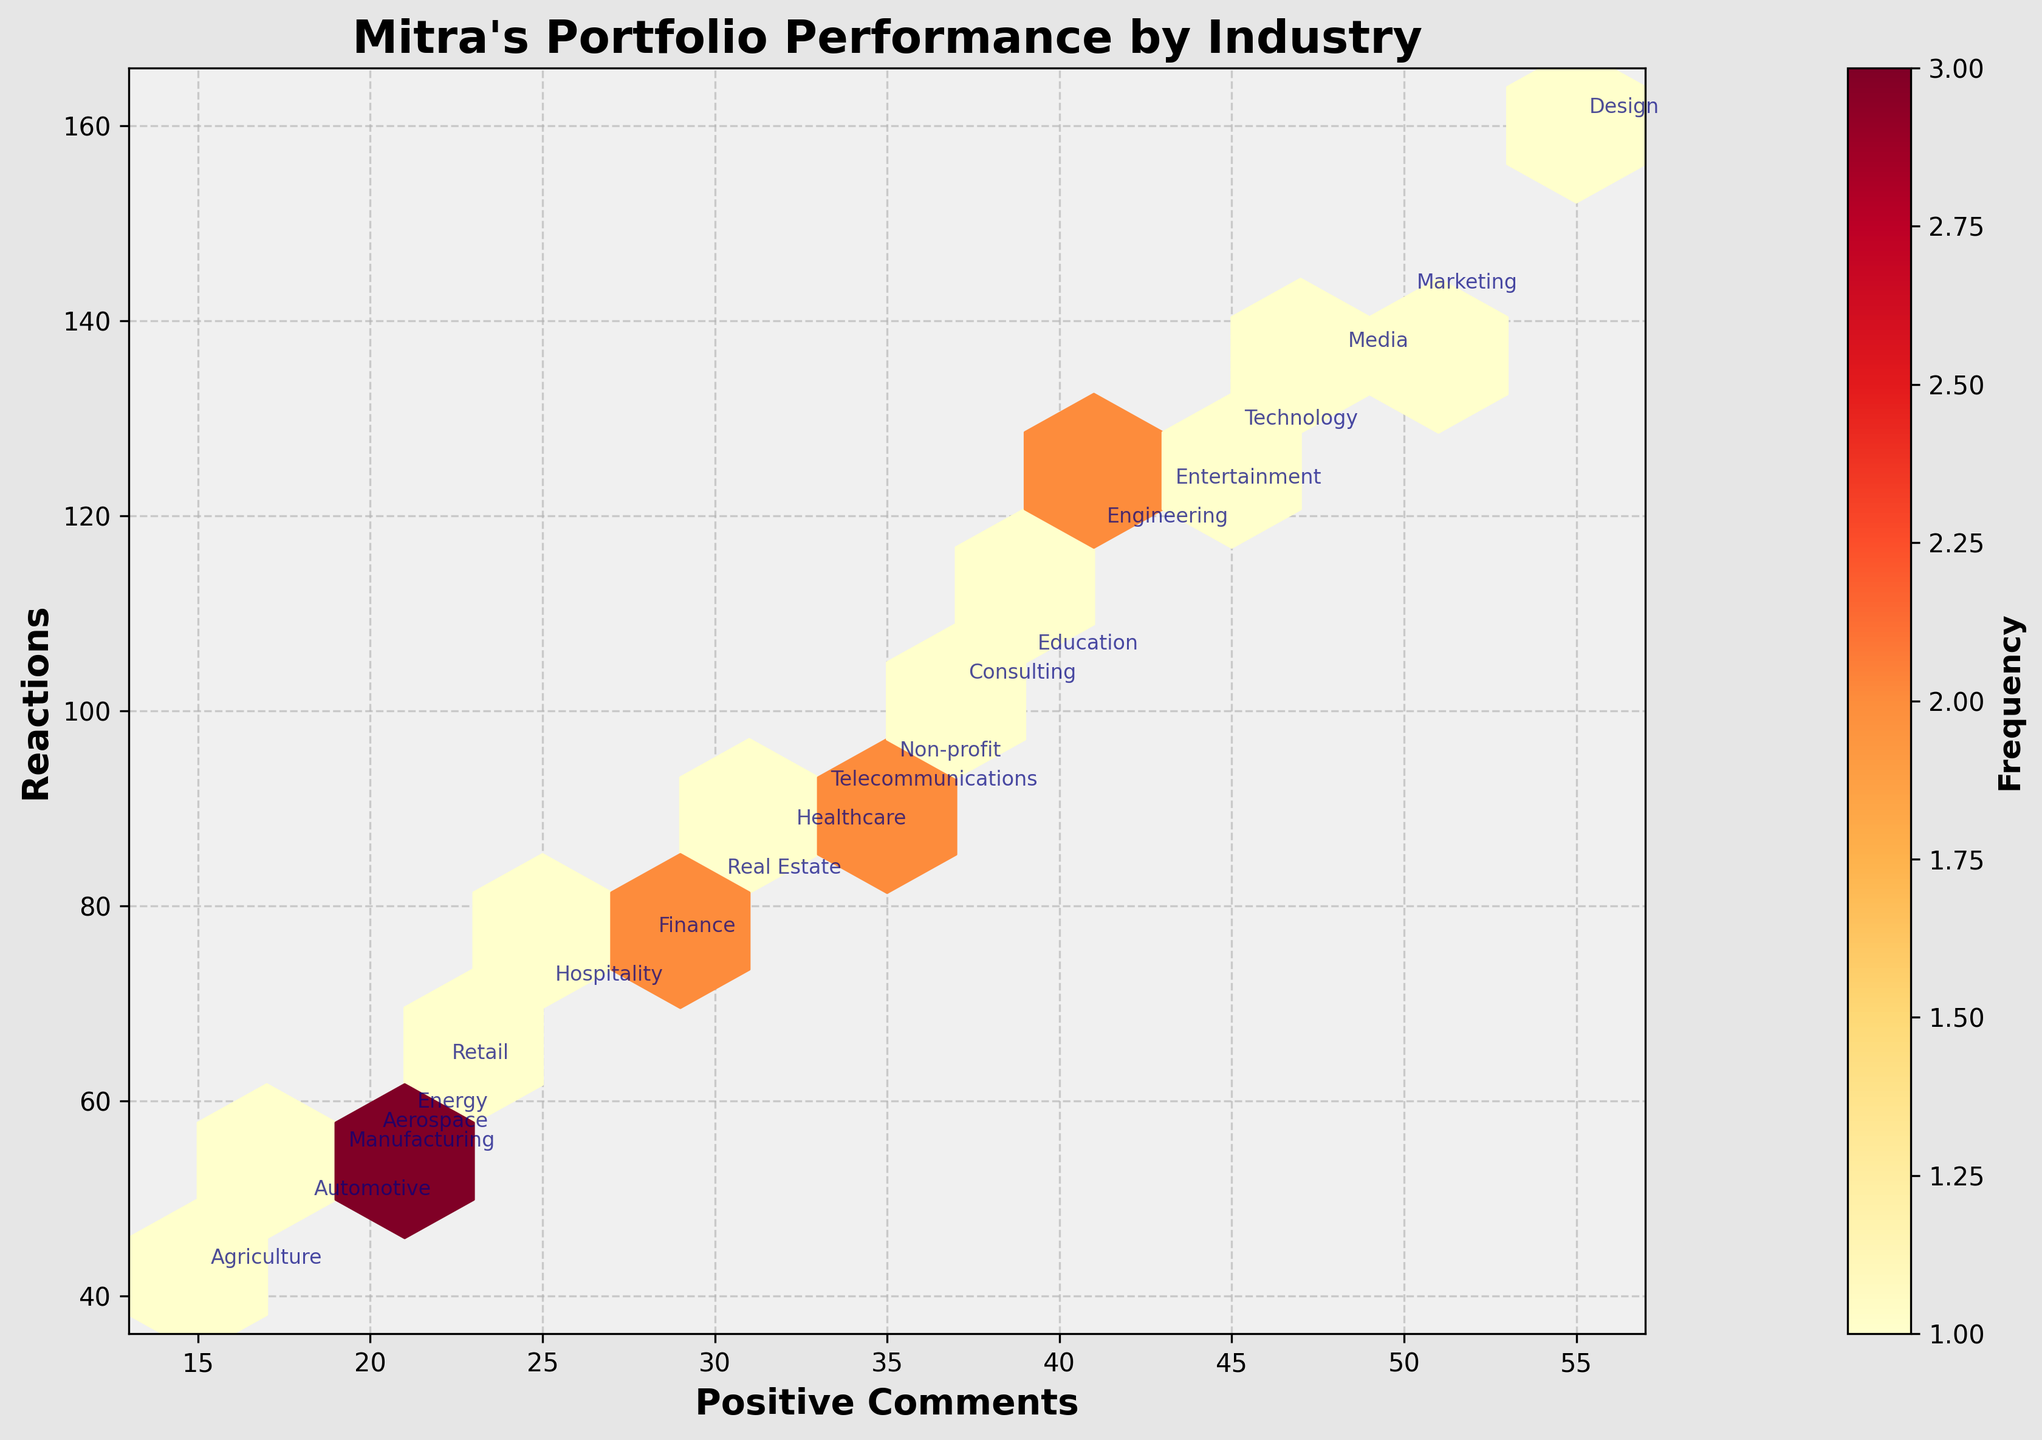What is the title of the hexbin plot? The first thing we notice at the top of the chart is the title, which is usually centered and in bold.
Answer: Mitra's Portfolio Performance by Industry What are the x-axis and y-axis labels in the hexbin plot? Looking at the axes, the x-axis label appears at the bottom of the plot and the y-axis label appears on the left side of the plot.
Answer: Positive Comments, Reactions How many total industry sectors are plotted on the hexbin plot? By identifying the distinct labels annotated on the plot, you can count the number of industry sectors mentioned.
Answer: 20 Which industry sector has the highest number of positive comments? By observing the axes and annotations, identify the point on the x-axis that corresponds to the highest number of positive comments.
Answer: Design Which data points lie within the darkest hexagons, indicating the highest frequency? Look for the darkest-colored hexagons on the plot which represent the highest frequency, and check the annotations nearby these sections.
Answer: Design, Marketing, and Technology sectors What is the range of positive comments and reactions values displayed in the plot? Observe the minimum and maximum values on the x and y axes to determine this range.
Answer: Positive Comments: 15-55, Reactions: 42-160 Which sector combination shows around 30 positive comments and fewer than 80 reactions? Locate the approximate position on the plot where the x value is around 30 and the y value is less than 80, and refer to the corresponding annotation.
Answer: Finance Between Technology and Healthcare, which sector has more reactions? Observe the y-axis values for the points labeled "Technology" and "Healthcare" to determine which one is higher.
Answer: Technology Are there any sectors with a similar number of positive comments but significantly different reactions? Identify any clusters where the x-axis values are similar but the y-axis values show a large disparity.
Answer: Education and Engineering Which sectors are in the hexagon that has a similar count as the one containing the "Non-profit" sector? Find the color and pattern of the hexagon containing "Non-profit" and identify other sectors sharing a hexagon of similar shading.
Answer: Education, Consulting 